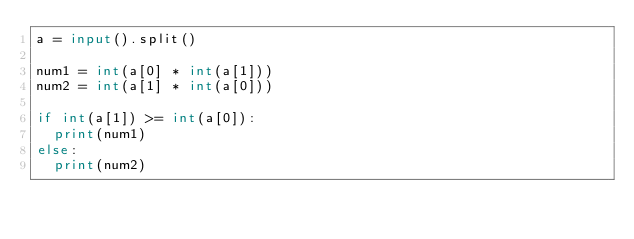<code> <loc_0><loc_0><loc_500><loc_500><_Python_>a = input().split()

num1 = int(a[0] * int(a[1]))
num2 = int(a[1] * int(a[0]))

if int(a[1]) >= int(a[0]):
  print(num1)
else:
  print(num2)
</code> 